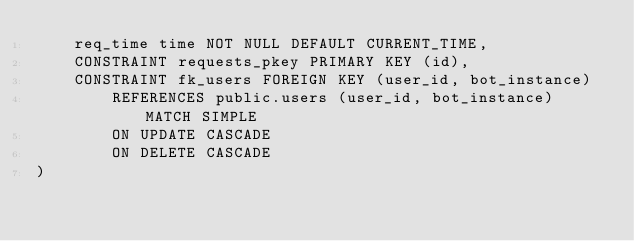Convert code to text. <code><loc_0><loc_0><loc_500><loc_500><_SQL_>    req_time time NOT NULL DEFAULT CURRENT_TIME,
    CONSTRAINT requests_pkey PRIMARY KEY (id),
    CONSTRAINT fk_users FOREIGN KEY (user_id, bot_instance)
        REFERENCES public.users (user_id, bot_instance) MATCH SIMPLE
        ON UPDATE CASCADE
        ON DELETE CASCADE
)</code> 